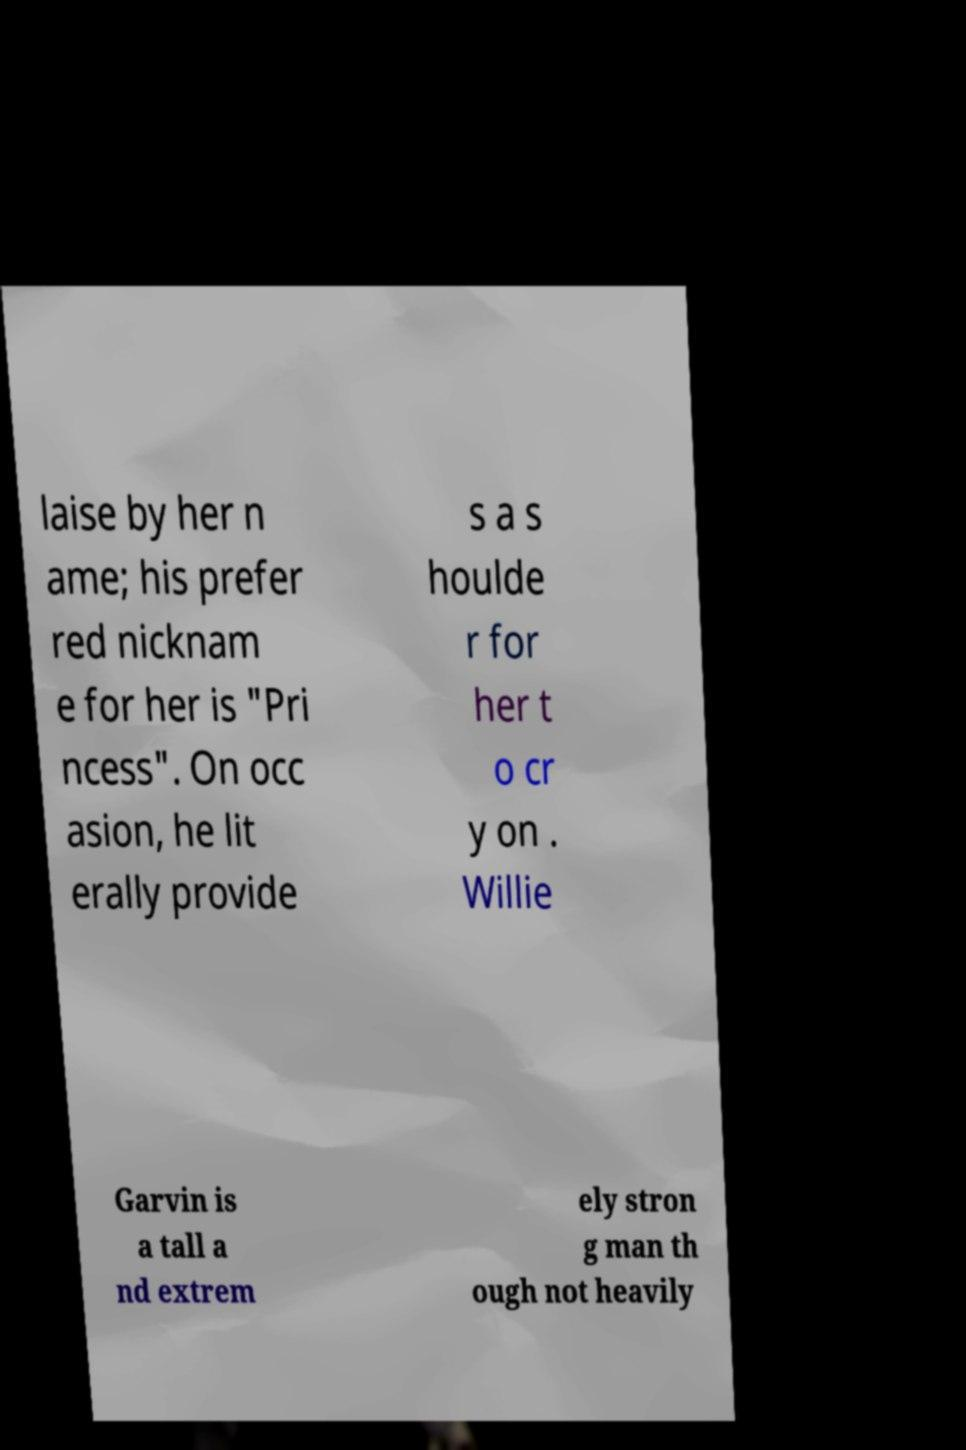What messages or text are displayed in this image? I need them in a readable, typed format. laise by her n ame; his prefer red nicknam e for her is "Pri ncess". On occ asion, he lit erally provide s a s houlde r for her t o cr y on . Willie Garvin is a tall a nd extrem ely stron g man th ough not heavily 